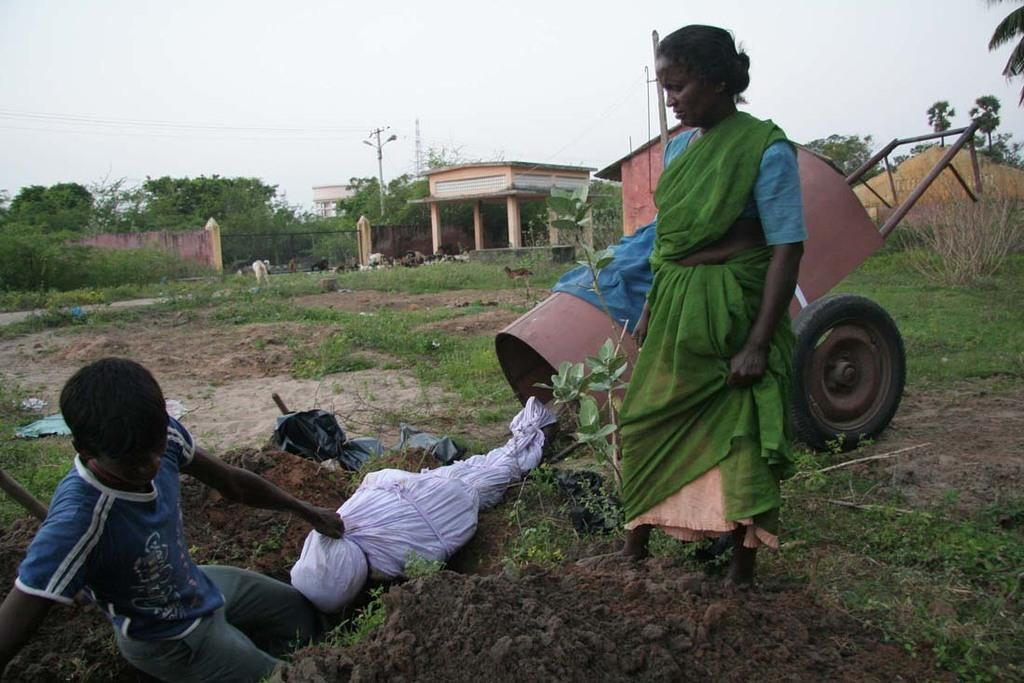How many people are in the image? There are two people in the image. What are the people doing in the image? The people are on a path. What is behind the people on the path? There is a cart behind the people. What structures can be seen in the image? There is a gate and a wall in the image. What type of vegetation is present in the image? There are trees in the image. What is the source of electricity in the image? There is an electric pole with cables in the image. What part of the natural environment is visible in the image? The sky is visible behind the trees. What type of clam is being used as a doorstop in the image? There is no clam present in the image, and therefore no such object is being used as a doorstop. 